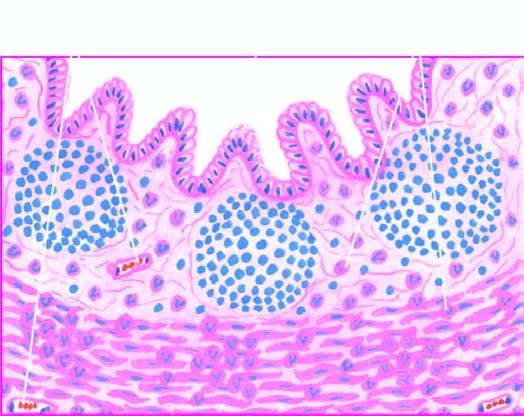re other changes present necrosis of mucosa and periappendicitis?
Answer the question using a single word or phrase. Yes 